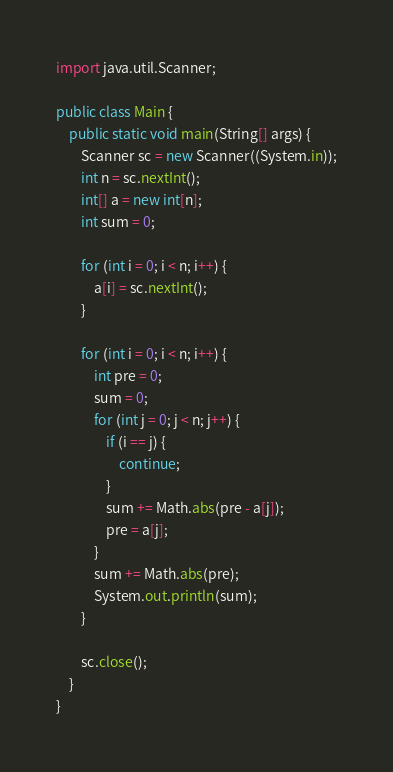Convert code to text. <code><loc_0><loc_0><loc_500><loc_500><_Java_>import java.util.Scanner;

public class Main {
	public static void main(String[] args) {
		Scanner sc = new Scanner((System.in));
		int n = sc.nextInt();
		int[] a = new int[n];
		int sum = 0;

		for (int i = 0; i < n; i++) {
			a[i] = sc.nextInt();
		}
		
		for (int i = 0; i < n; i++) {
			int pre = 0;
			sum = 0;
			for (int j = 0; j < n; j++) {
				if (i == j) {
					continue;
				}
				sum += Math.abs(pre - a[j]);
				pre = a[j];
			}
			sum += Math.abs(pre);
			System.out.println(sum);
		}
		
		sc.close();
	}
}
</code> 